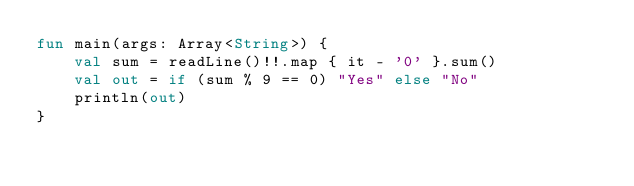<code> <loc_0><loc_0><loc_500><loc_500><_Kotlin_>fun main(args: Array<String>) {
    val sum = readLine()!!.map { it - '0' }.sum()
    val out = if (sum % 9 == 0) "Yes" else "No"
    println(out)
}</code> 